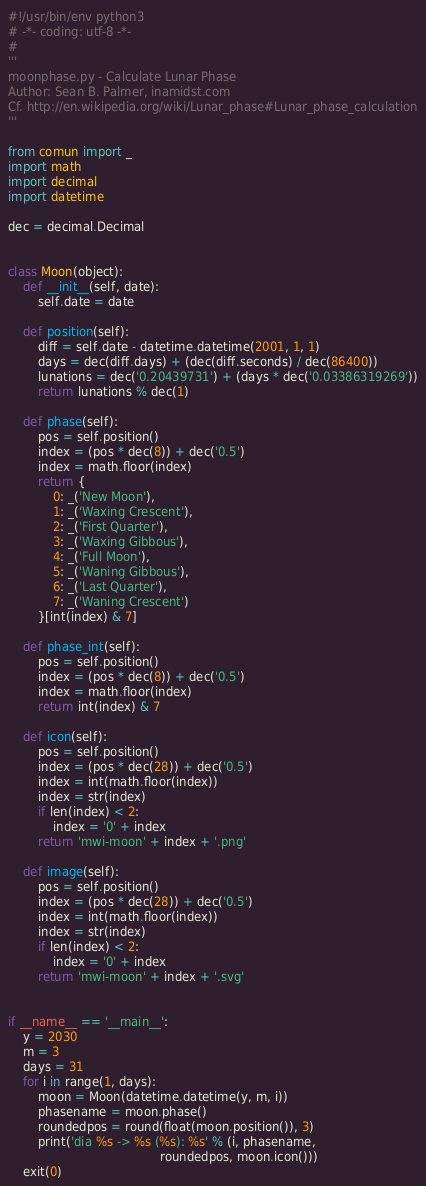<code> <loc_0><loc_0><loc_500><loc_500><_Python_>#!/usr/bin/env python3
# -*- coding: utf-8 -*-
#
'''
moonphase.py - Calculate Lunar Phase
Author: Sean B. Palmer, inamidst.com
Cf. http://en.wikipedia.org/wiki/Lunar_phase#Lunar_phase_calculation
'''

from comun import _
import math
import decimal
import datetime

dec = decimal.Decimal


class Moon(object):
    def __init__(self, date):
        self.date = date

    def position(self):
        diff = self.date - datetime.datetime(2001, 1, 1)
        days = dec(diff.days) + (dec(diff.seconds) / dec(86400))
        lunations = dec('0.20439731') + (days * dec('0.03386319269'))
        return lunations % dec(1)

    def phase(self):
        pos = self.position()
        index = (pos * dec(8)) + dec('0.5')
        index = math.floor(index)
        return {
            0: _('New Moon'),
            1: _('Waxing Crescent'),
            2: _('First Quarter'),
            3: _('Waxing Gibbous'),
            4: _('Full Moon'),
            5: _('Waning Gibbous'),
            6: _('Last Quarter'),
            7: _('Waning Crescent')
        }[int(index) & 7]

    def phase_int(self):
        pos = self.position()
        index = (pos * dec(8)) + dec('0.5')
        index = math.floor(index)
        return int(index) & 7

    def icon(self):
        pos = self.position()
        index = (pos * dec(28)) + dec('0.5')
        index = int(math.floor(index))
        index = str(index)
        if len(index) < 2:
            index = '0' + index
        return 'mwi-moon' + index + '.png'

    def image(self):
        pos = self.position()
        index = (pos * dec(28)) + dec('0.5')
        index = int(math.floor(index))
        index = str(index)
        if len(index) < 2:
            index = '0' + index
        return 'mwi-moon' + index + '.svg'


if __name__ == '__main__':
    y = 2030
    m = 3
    days = 31
    for i in range(1, days):
        moon = Moon(datetime.datetime(y, m, i))
        phasename = moon.phase()
        roundedpos = round(float(moon.position()), 3)
        print('dia %s -> %s (%s): %s' % (i, phasename,
                                         roundedpos, moon.icon()))
    exit(0)
</code> 